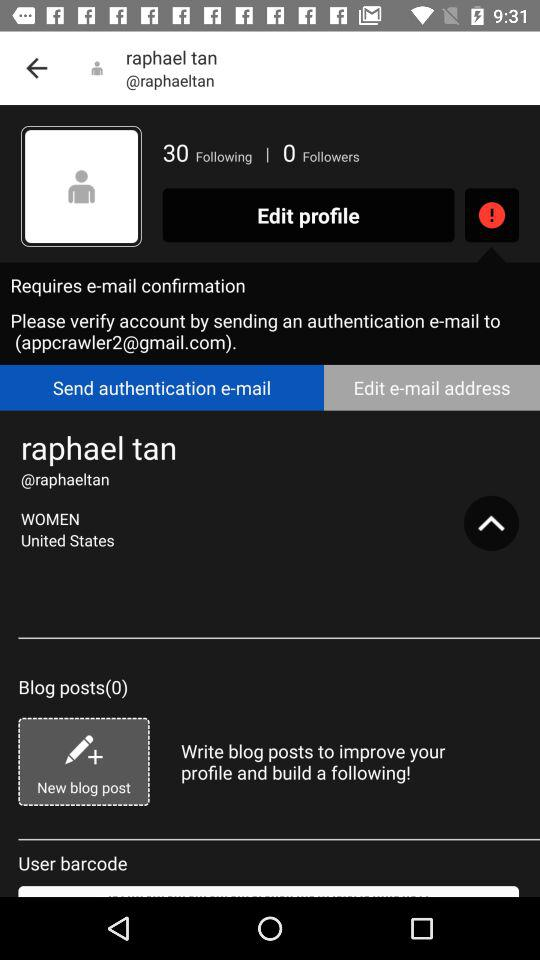What Gmail address is used to verify the account? The used Gmail address is appcrawler2@gmail.com. 